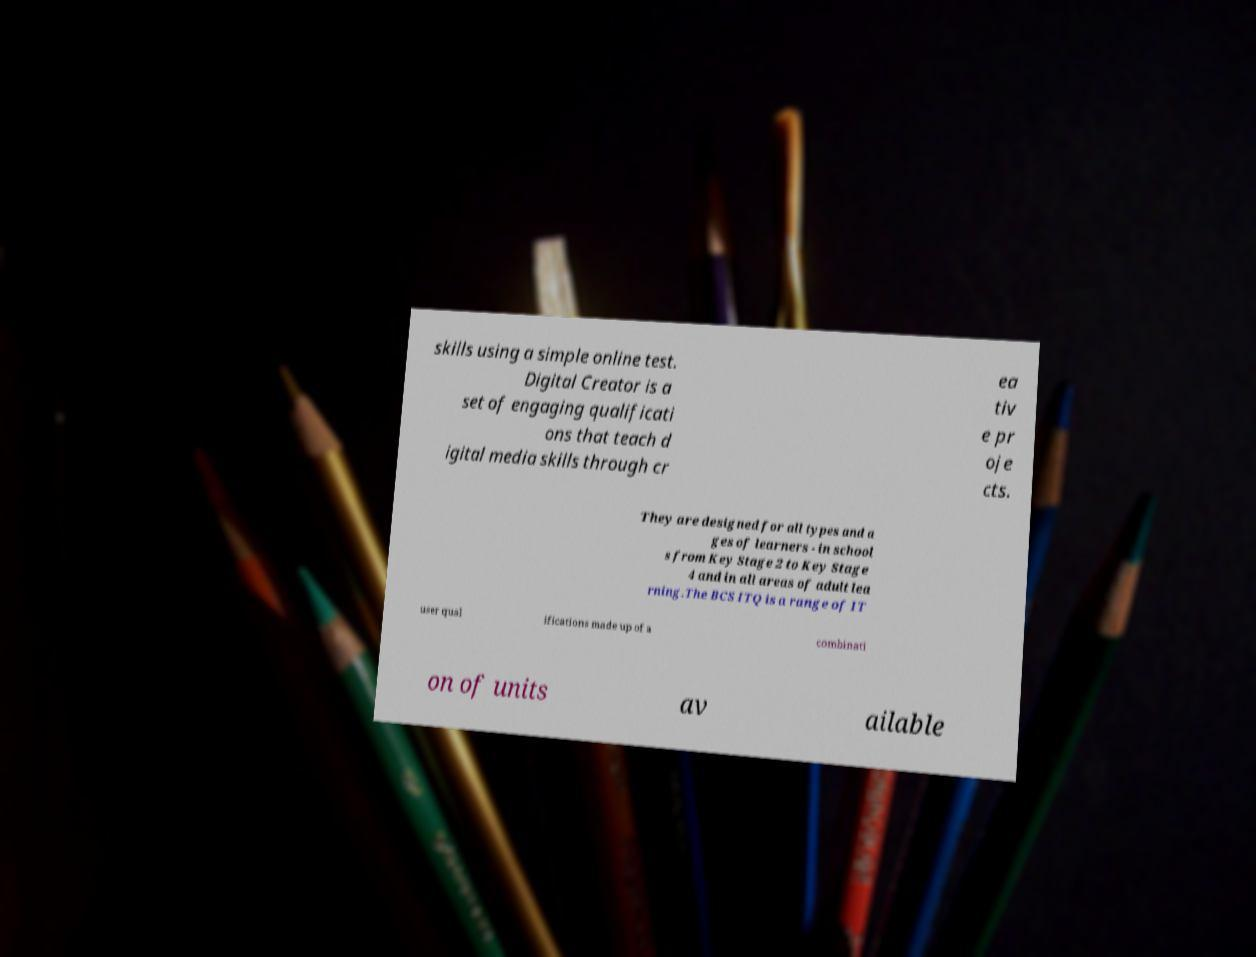What messages or text are displayed in this image? I need them in a readable, typed format. skills using a simple online test. Digital Creator is a set of engaging qualificati ons that teach d igital media skills through cr ea tiv e pr oje cts. They are designed for all types and a ges of learners - in school s from Key Stage 2 to Key Stage 4 and in all areas of adult lea rning.The BCS ITQ is a range of IT user qual ifications made up of a combinati on of units av ailable 